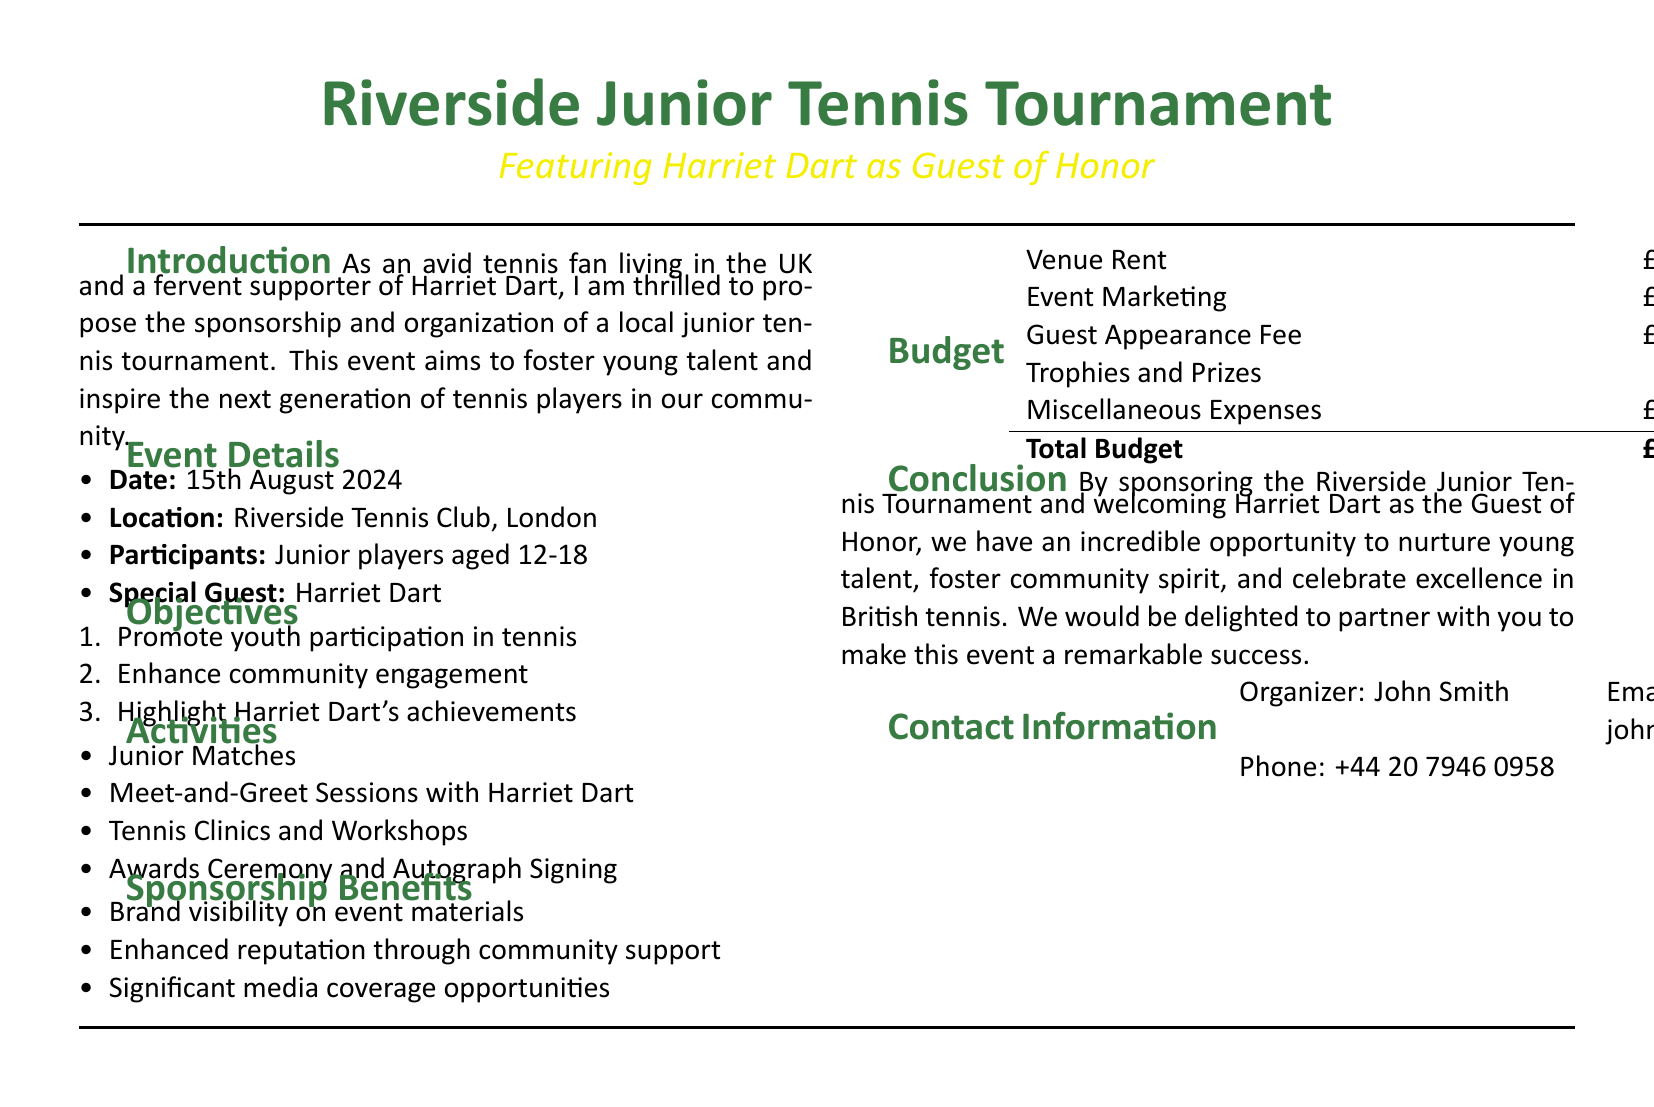What is the date of the tournament? The date is explicitly mentioned in the event details section of the document.
Answer: 15th August 2024 Where will the tournament take place? The location is specified in the event details section.
Answer: Riverside Tennis Club, London Who is the special guest for the event? The document states that Harriet Dart will be the special guest.
Answer: Harriet Dart What are the age groups for participants? The participant age range is given in the event details section.
Answer: Aged 12-18 What is the total budget for the tournament? The total budget is clearly listed in the budget section of the document.
Answer: £8,500 What type of activities will be held during the tournament? Activities include both matches and engagement sessions as indicated in the activities section.
Answer: Junior Matches, Meet-and-Greet Sessions, Tennis Clinics, Awards Ceremony What is one of the objectives of the tournament? The objectives in the proposal detail the aims of the tournament, which includes promoting engagement and talent.
Answer: Promote youth participation in tennis What benefit does a sponsor receive regarding media? The sponsorship benefits section mentions the media aspect of sponsorship.
Answer: Significant media coverage opportunities What is the fee for Harriet Dart's appearance? The guest appearance fee is listed in the budget section.
Answer: £3,000 